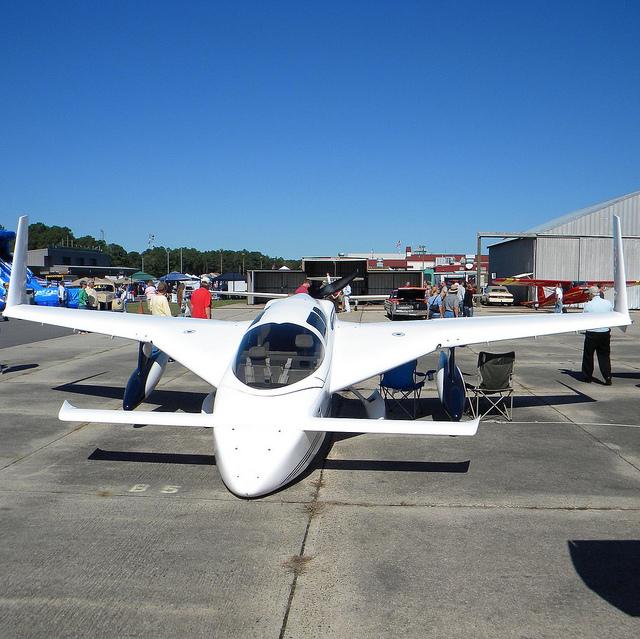Are there clouds in the sky?
Quick response, please. No. Can you take this vehicle to a drive in movie theater?
Answer briefly. No. Is this a commercial airliner?
Write a very short answer. No. What color is the plane?
Keep it brief. White. 